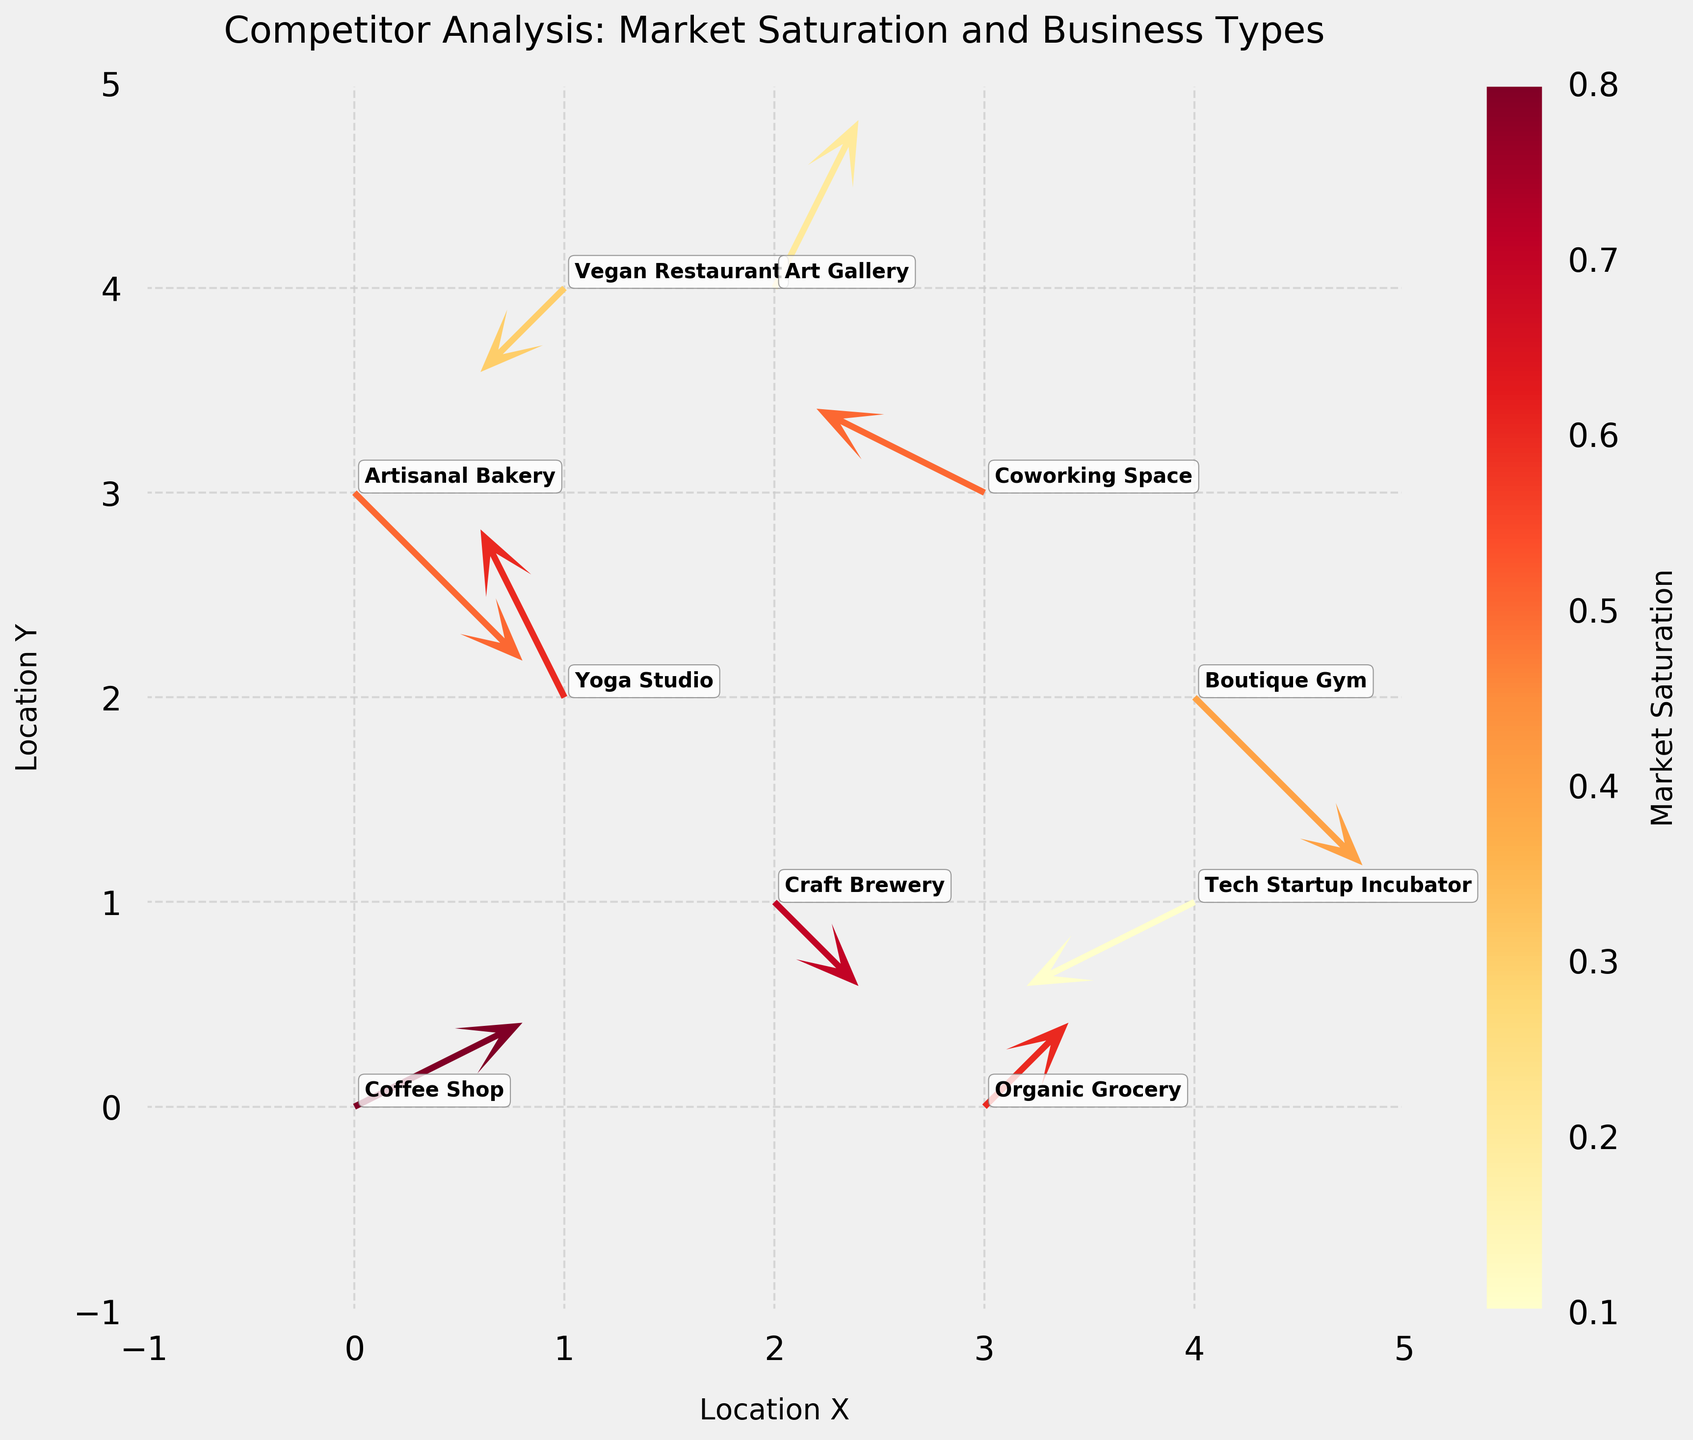What is the highest market saturation displayed in the figure? The color of the quivers represents market saturation. The darkest colored quiver, indicating the highest market saturation, is that of the "Coffee Shop" with a value of 0.8.
Answer: 0.8 Which business type has the lowest market saturation? Among the data points, the "Tech Startup Incubator" has the lightest color, indicating the lowest market saturation of 0.1.
Answer: Tech Startup Incubator How many data points are there in total on the plot? By counting each business type labeled on the plot, we find a total of 10 data points.
Answer: 10 Which business types are located at the coordinate (2, 4)? According to the labels near the coordinate (2, 4) on the plot, the business type located there is "Art Gallery".
Answer: Art Gallery What is the direction of the vector for the "Craft Brewery"? The "Craft Brewery" vector starts at (2, 1) and points in the direction of (1, -1), which indicates a southward and slightly westward direction.
Answer: South-West How does the market saturation of "Yoga Studio" compare with that of "Boutique Gym"? The "Yoga Studio" has a market saturation of 0.6, while the "Boutique Gym" has a market saturation of 0.4, indicating that the Yoga Studio has a higher market saturation.
Answer: Yoga Studio has higher market saturation What is the sum of the market saturations for "Organic Grocery" and "Artisanal Bakery"? The market saturation for "Organic Grocery" is 0.6 and for "Artisanal Bakery" is 0.5. Adding these together results in 0.6 + 0.5 = 1.1.
Answer: 1.1 Which business type is moving the furthest in a positive y-direction? By examining the length and direction of quiver vectors, the "Yoga Studio" vector moves the furthest in the positive y-direction, ending at (1, 4).
Answer: Yoga Studio What business type is located at (4, 1) and what is its quiver direction? The coordinate (4, 1) corresponds to a "Tech Startup Incubator", with its quiver pointing southwestward in the (-2, -1) direction.
Answer: Tech Startup Incubator, southwest What is the average market saturation of all business types displayed in the plot? The market saturations are 0.8, 0.6, 0.7, 0.5, 0.4, 0.3, 0.2, 0.1, 0.6, and 0.5. Summing them results in \(0.8 + 0.6 + 0.7 + 0.5 + 0.4 + 0.3 + 0.2 + 0.1 + 0.6 + 0.5 = 4.7\). Dividing by 10 gives an average of \(4.7 / 10 = 0.47\).
Answer: 0.47 